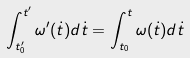<formula> <loc_0><loc_0><loc_500><loc_500>\int _ { t _ { 0 } ^ { \prime } } ^ { t ^ { \prime } } { \omega ^ { \prime } ( \dot { t } ) d \dot { t } } = \int _ { t _ { 0 } } ^ { t } { \omega ( \dot { t } ) d \dot { t } }</formula> 